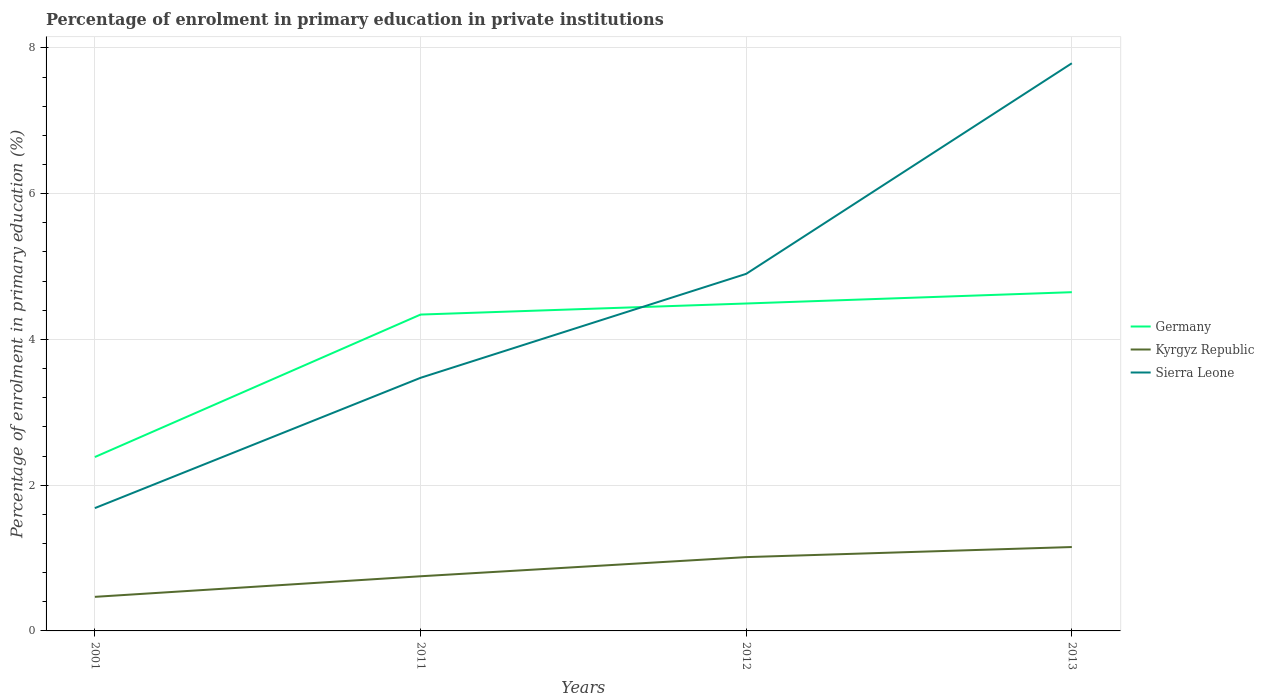How many different coloured lines are there?
Offer a terse response. 3. Across all years, what is the maximum percentage of enrolment in primary education in Sierra Leone?
Provide a short and direct response. 1.69. In which year was the percentage of enrolment in primary education in Sierra Leone maximum?
Your answer should be compact. 2001. What is the total percentage of enrolment in primary education in Germany in the graph?
Your answer should be very brief. -2.26. What is the difference between the highest and the second highest percentage of enrolment in primary education in Germany?
Make the answer very short. 2.26. What is the difference between the highest and the lowest percentage of enrolment in primary education in Kyrgyz Republic?
Provide a succinct answer. 2. Is the percentage of enrolment in primary education in Germany strictly greater than the percentage of enrolment in primary education in Kyrgyz Republic over the years?
Make the answer very short. No. What is the difference between two consecutive major ticks on the Y-axis?
Give a very brief answer. 2. Are the values on the major ticks of Y-axis written in scientific E-notation?
Ensure brevity in your answer.  No. Does the graph contain any zero values?
Keep it short and to the point. No. Does the graph contain grids?
Offer a very short reply. Yes. How many legend labels are there?
Provide a short and direct response. 3. How are the legend labels stacked?
Provide a short and direct response. Vertical. What is the title of the graph?
Your answer should be compact. Percentage of enrolment in primary education in private institutions. What is the label or title of the Y-axis?
Your answer should be compact. Percentage of enrolment in primary education (%). What is the Percentage of enrolment in primary education (%) of Germany in 2001?
Ensure brevity in your answer.  2.39. What is the Percentage of enrolment in primary education (%) in Kyrgyz Republic in 2001?
Provide a succinct answer. 0.47. What is the Percentage of enrolment in primary education (%) of Sierra Leone in 2001?
Give a very brief answer. 1.69. What is the Percentage of enrolment in primary education (%) of Germany in 2011?
Offer a very short reply. 4.34. What is the Percentage of enrolment in primary education (%) of Kyrgyz Republic in 2011?
Give a very brief answer. 0.75. What is the Percentage of enrolment in primary education (%) of Sierra Leone in 2011?
Provide a short and direct response. 3.47. What is the Percentage of enrolment in primary education (%) in Germany in 2012?
Keep it short and to the point. 4.49. What is the Percentage of enrolment in primary education (%) in Kyrgyz Republic in 2012?
Offer a very short reply. 1.01. What is the Percentage of enrolment in primary education (%) in Sierra Leone in 2012?
Your answer should be compact. 4.9. What is the Percentage of enrolment in primary education (%) in Germany in 2013?
Provide a short and direct response. 4.65. What is the Percentage of enrolment in primary education (%) in Kyrgyz Republic in 2013?
Your answer should be compact. 1.15. What is the Percentage of enrolment in primary education (%) of Sierra Leone in 2013?
Offer a terse response. 7.79. Across all years, what is the maximum Percentage of enrolment in primary education (%) of Germany?
Make the answer very short. 4.65. Across all years, what is the maximum Percentage of enrolment in primary education (%) of Kyrgyz Republic?
Ensure brevity in your answer.  1.15. Across all years, what is the maximum Percentage of enrolment in primary education (%) of Sierra Leone?
Ensure brevity in your answer.  7.79. Across all years, what is the minimum Percentage of enrolment in primary education (%) of Germany?
Provide a succinct answer. 2.39. Across all years, what is the minimum Percentage of enrolment in primary education (%) in Kyrgyz Republic?
Ensure brevity in your answer.  0.47. Across all years, what is the minimum Percentage of enrolment in primary education (%) in Sierra Leone?
Offer a very short reply. 1.69. What is the total Percentage of enrolment in primary education (%) in Germany in the graph?
Offer a terse response. 15.87. What is the total Percentage of enrolment in primary education (%) in Kyrgyz Republic in the graph?
Provide a succinct answer. 3.38. What is the total Percentage of enrolment in primary education (%) in Sierra Leone in the graph?
Provide a short and direct response. 17.85. What is the difference between the Percentage of enrolment in primary education (%) of Germany in 2001 and that in 2011?
Your answer should be very brief. -1.95. What is the difference between the Percentage of enrolment in primary education (%) of Kyrgyz Republic in 2001 and that in 2011?
Provide a succinct answer. -0.28. What is the difference between the Percentage of enrolment in primary education (%) in Sierra Leone in 2001 and that in 2011?
Offer a very short reply. -1.79. What is the difference between the Percentage of enrolment in primary education (%) of Germany in 2001 and that in 2012?
Your response must be concise. -2.11. What is the difference between the Percentage of enrolment in primary education (%) of Kyrgyz Republic in 2001 and that in 2012?
Provide a short and direct response. -0.55. What is the difference between the Percentage of enrolment in primary education (%) of Sierra Leone in 2001 and that in 2012?
Provide a succinct answer. -3.21. What is the difference between the Percentage of enrolment in primary education (%) of Germany in 2001 and that in 2013?
Your answer should be compact. -2.26. What is the difference between the Percentage of enrolment in primary education (%) in Kyrgyz Republic in 2001 and that in 2013?
Provide a short and direct response. -0.68. What is the difference between the Percentage of enrolment in primary education (%) in Sierra Leone in 2001 and that in 2013?
Your answer should be compact. -6.1. What is the difference between the Percentage of enrolment in primary education (%) of Germany in 2011 and that in 2012?
Keep it short and to the point. -0.15. What is the difference between the Percentage of enrolment in primary education (%) of Kyrgyz Republic in 2011 and that in 2012?
Offer a very short reply. -0.26. What is the difference between the Percentage of enrolment in primary education (%) of Sierra Leone in 2011 and that in 2012?
Offer a very short reply. -1.43. What is the difference between the Percentage of enrolment in primary education (%) of Germany in 2011 and that in 2013?
Ensure brevity in your answer.  -0.31. What is the difference between the Percentage of enrolment in primary education (%) in Kyrgyz Republic in 2011 and that in 2013?
Offer a terse response. -0.4. What is the difference between the Percentage of enrolment in primary education (%) in Sierra Leone in 2011 and that in 2013?
Provide a succinct answer. -4.32. What is the difference between the Percentage of enrolment in primary education (%) of Germany in 2012 and that in 2013?
Your answer should be very brief. -0.16. What is the difference between the Percentage of enrolment in primary education (%) of Kyrgyz Republic in 2012 and that in 2013?
Offer a very short reply. -0.14. What is the difference between the Percentage of enrolment in primary education (%) in Sierra Leone in 2012 and that in 2013?
Your response must be concise. -2.89. What is the difference between the Percentage of enrolment in primary education (%) of Germany in 2001 and the Percentage of enrolment in primary education (%) of Kyrgyz Republic in 2011?
Offer a terse response. 1.64. What is the difference between the Percentage of enrolment in primary education (%) of Germany in 2001 and the Percentage of enrolment in primary education (%) of Sierra Leone in 2011?
Offer a very short reply. -1.09. What is the difference between the Percentage of enrolment in primary education (%) in Kyrgyz Republic in 2001 and the Percentage of enrolment in primary education (%) in Sierra Leone in 2011?
Your answer should be compact. -3.01. What is the difference between the Percentage of enrolment in primary education (%) of Germany in 2001 and the Percentage of enrolment in primary education (%) of Kyrgyz Republic in 2012?
Offer a terse response. 1.37. What is the difference between the Percentage of enrolment in primary education (%) of Germany in 2001 and the Percentage of enrolment in primary education (%) of Sierra Leone in 2012?
Your answer should be very brief. -2.51. What is the difference between the Percentage of enrolment in primary education (%) in Kyrgyz Republic in 2001 and the Percentage of enrolment in primary education (%) in Sierra Leone in 2012?
Ensure brevity in your answer.  -4.43. What is the difference between the Percentage of enrolment in primary education (%) of Germany in 2001 and the Percentage of enrolment in primary education (%) of Kyrgyz Republic in 2013?
Make the answer very short. 1.24. What is the difference between the Percentage of enrolment in primary education (%) in Germany in 2001 and the Percentage of enrolment in primary education (%) in Sierra Leone in 2013?
Give a very brief answer. -5.4. What is the difference between the Percentage of enrolment in primary education (%) in Kyrgyz Republic in 2001 and the Percentage of enrolment in primary education (%) in Sierra Leone in 2013?
Provide a short and direct response. -7.32. What is the difference between the Percentage of enrolment in primary education (%) in Germany in 2011 and the Percentage of enrolment in primary education (%) in Kyrgyz Republic in 2012?
Offer a very short reply. 3.33. What is the difference between the Percentage of enrolment in primary education (%) of Germany in 2011 and the Percentage of enrolment in primary education (%) of Sierra Leone in 2012?
Ensure brevity in your answer.  -0.56. What is the difference between the Percentage of enrolment in primary education (%) in Kyrgyz Republic in 2011 and the Percentage of enrolment in primary education (%) in Sierra Leone in 2012?
Your answer should be very brief. -4.15. What is the difference between the Percentage of enrolment in primary education (%) in Germany in 2011 and the Percentage of enrolment in primary education (%) in Kyrgyz Republic in 2013?
Provide a succinct answer. 3.19. What is the difference between the Percentage of enrolment in primary education (%) of Germany in 2011 and the Percentage of enrolment in primary education (%) of Sierra Leone in 2013?
Ensure brevity in your answer.  -3.45. What is the difference between the Percentage of enrolment in primary education (%) in Kyrgyz Republic in 2011 and the Percentage of enrolment in primary education (%) in Sierra Leone in 2013?
Provide a succinct answer. -7.04. What is the difference between the Percentage of enrolment in primary education (%) in Germany in 2012 and the Percentage of enrolment in primary education (%) in Kyrgyz Republic in 2013?
Your response must be concise. 3.34. What is the difference between the Percentage of enrolment in primary education (%) of Germany in 2012 and the Percentage of enrolment in primary education (%) of Sierra Leone in 2013?
Keep it short and to the point. -3.3. What is the difference between the Percentage of enrolment in primary education (%) in Kyrgyz Republic in 2012 and the Percentage of enrolment in primary education (%) in Sierra Leone in 2013?
Make the answer very short. -6.78. What is the average Percentage of enrolment in primary education (%) of Germany per year?
Provide a succinct answer. 3.97. What is the average Percentage of enrolment in primary education (%) in Kyrgyz Republic per year?
Keep it short and to the point. 0.85. What is the average Percentage of enrolment in primary education (%) in Sierra Leone per year?
Provide a succinct answer. 4.46. In the year 2001, what is the difference between the Percentage of enrolment in primary education (%) of Germany and Percentage of enrolment in primary education (%) of Kyrgyz Republic?
Offer a very short reply. 1.92. In the year 2001, what is the difference between the Percentage of enrolment in primary education (%) in Germany and Percentage of enrolment in primary education (%) in Sierra Leone?
Make the answer very short. 0.7. In the year 2001, what is the difference between the Percentage of enrolment in primary education (%) in Kyrgyz Republic and Percentage of enrolment in primary education (%) in Sierra Leone?
Make the answer very short. -1.22. In the year 2011, what is the difference between the Percentage of enrolment in primary education (%) of Germany and Percentage of enrolment in primary education (%) of Kyrgyz Republic?
Your answer should be compact. 3.59. In the year 2011, what is the difference between the Percentage of enrolment in primary education (%) in Germany and Percentage of enrolment in primary education (%) in Sierra Leone?
Your answer should be compact. 0.87. In the year 2011, what is the difference between the Percentage of enrolment in primary education (%) in Kyrgyz Republic and Percentage of enrolment in primary education (%) in Sierra Leone?
Keep it short and to the point. -2.72. In the year 2012, what is the difference between the Percentage of enrolment in primary education (%) of Germany and Percentage of enrolment in primary education (%) of Kyrgyz Republic?
Provide a succinct answer. 3.48. In the year 2012, what is the difference between the Percentage of enrolment in primary education (%) of Germany and Percentage of enrolment in primary education (%) of Sierra Leone?
Provide a succinct answer. -0.41. In the year 2012, what is the difference between the Percentage of enrolment in primary education (%) in Kyrgyz Republic and Percentage of enrolment in primary education (%) in Sierra Leone?
Keep it short and to the point. -3.89. In the year 2013, what is the difference between the Percentage of enrolment in primary education (%) of Germany and Percentage of enrolment in primary education (%) of Kyrgyz Republic?
Offer a terse response. 3.5. In the year 2013, what is the difference between the Percentage of enrolment in primary education (%) in Germany and Percentage of enrolment in primary education (%) in Sierra Leone?
Offer a terse response. -3.14. In the year 2013, what is the difference between the Percentage of enrolment in primary education (%) in Kyrgyz Republic and Percentage of enrolment in primary education (%) in Sierra Leone?
Make the answer very short. -6.64. What is the ratio of the Percentage of enrolment in primary education (%) in Germany in 2001 to that in 2011?
Make the answer very short. 0.55. What is the ratio of the Percentage of enrolment in primary education (%) in Kyrgyz Republic in 2001 to that in 2011?
Offer a terse response. 0.62. What is the ratio of the Percentage of enrolment in primary education (%) in Sierra Leone in 2001 to that in 2011?
Offer a very short reply. 0.49. What is the ratio of the Percentage of enrolment in primary education (%) of Germany in 2001 to that in 2012?
Make the answer very short. 0.53. What is the ratio of the Percentage of enrolment in primary education (%) in Kyrgyz Republic in 2001 to that in 2012?
Keep it short and to the point. 0.46. What is the ratio of the Percentage of enrolment in primary education (%) in Sierra Leone in 2001 to that in 2012?
Your answer should be compact. 0.34. What is the ratio of the Percentage of enrolment in primary education (%) in Germany in 2001 to that in 2013?
Provide a short and direct response. 0.51. What is the ratio of the Percentage of enrolment in primary education (%) of Kyrgyz Republic in 2001 to that in 2013?
Offer a very short reply. 0.41. What is the ratio of the Percentage of enrolment in primary education (%) of Sierra Leone in 2001 to that in 2013?
Offer a very short reply. 0.22. What is the ratio of the Percentage of enrolment in primary education (%) in Germany in 2011 to that in 2012?
Your response must be concise. 0.97. What is the ratio of the Percentage of enrolment in primary education (%) in Kyrgyz Republic in 2011 to that in 2012?
Offer a very short reply. 0.74. What is the ratio of the Percentage of enrolment in primary education (%) of Sierra Leone in 2011 to that in 2012?
Your answer should be very brief. 0.71. What is the ratio of the Percentage of enrolment in primary education (%) in Germany in 2011 to that in 2013?
Give a very brief answer. 0.93. What is the ratio of the Percentage of enrolment in primary education (%) of Kyrgyz Republic in 2011 to that in 2013?
Provide a short and direct response. 0.65. What is the ratio of the Percentage of enrolment in primary education (%) of Sierra Leone in 2011 to that in 2013?
Provide a short and direct response. 0.45. What is the ratio of the Percentage of enrolment in primary education (%) of Germany in 2012 to that in 2013?
Provide a succinct answer. 0.97. What is the ratio of the Percentage of enrolment in primary education (%) in Kyrgyz Republic in 2012 to that in 2013?
Your answer should be compact. 0.88. What is the ratio of the Percentage of enrolment in primary education (%) in Sierra Leone in 2012 to that in 2013?
Your response must be concise. 0.63. What is the difference between the highest and the second highest Percentage of enrolment in primary education (%) in Germany?
Make the answer very short. 0.16. What is the difference between the highest and the second highest Percentage of enrolment in primary education (%) of Kyrgyz Republic?
Offer a very short reply. 0.14. What is the difference between the highest and the second highest Percentage of enrolment in primary education (%) of Sierra Leone?
Ensure brevity in your answer.  2.89. What is the difference between the highest and the lowest Percentage of enrolment in primary education (%) in Germany?
Keep it short and to the point. 2.26. What is the difference between the highest and the lowest Percentage of enrolment in primary education (%) of Kyrgyz Republic?
Your answer should be compact. 0.68. What is the difference between the highest and the lowest Percentage of enrolment in primary education (%) of Sierra Leone?
Keep it short and to the point. 6.1. 